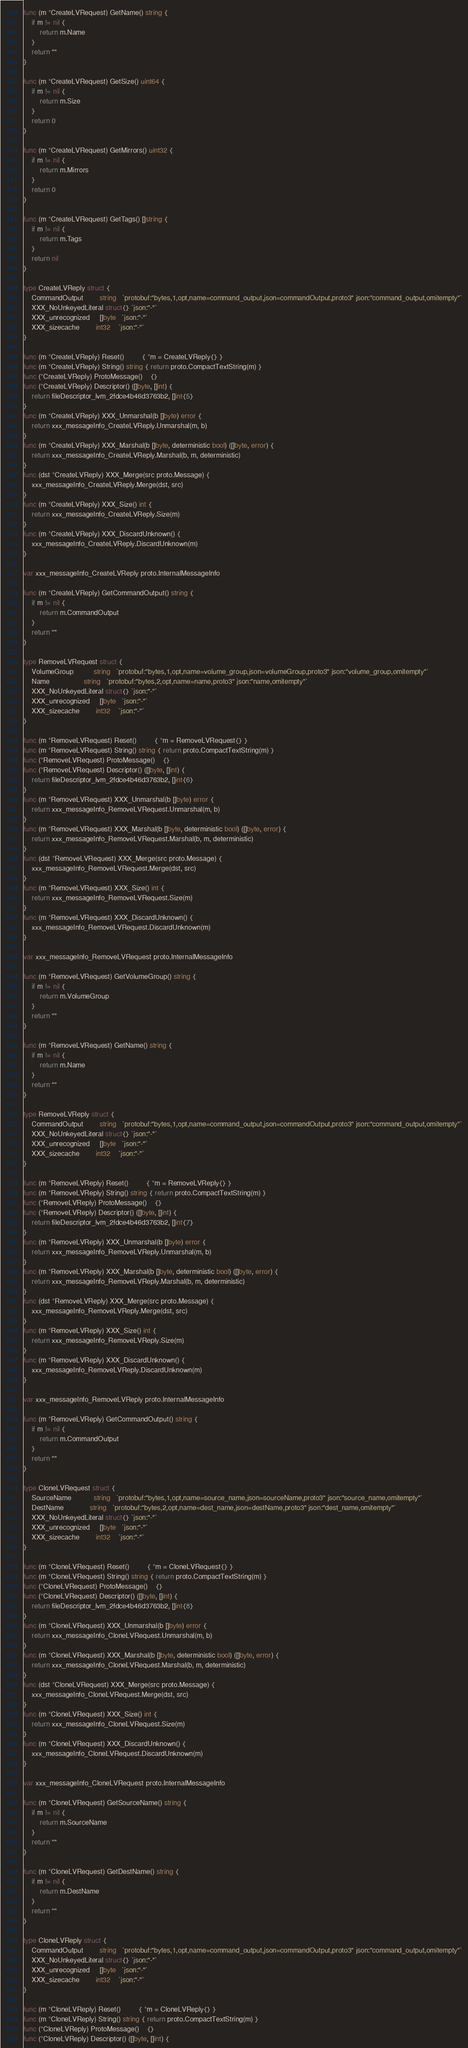<code> <loc_0><loc_0><loc_500><loc_500><_Go_>func (m *CreateLVRequest) GetName() string {
	if m != nil {
		return m.Name
	}
	return ""
}

func (m *CreateLVRequest) GetSize() uint64 {
	if m != nil {
		return m.Size
	}
	return 0
}

func (m *CreateLVRequest) GetMirrors() uint32 {
	if m != nil {
		return m.Mirrors
	}
	return 0
}

func (m *CreateLVRequest) GetTags() []string {
	if m != nil {
		return m.Tags
	}
	return nil
}

type CreateLVReply struct {
	CommandOutput        string   `protobuf:"bytes,1,opt,name=command_output,json=commandOutput,proto3" json:"command_output,omitempty"`
	XXX_NoUnkeyedLiteral struct{} `json:"-"`
	XXX_unrecognized     []byte   `json:"-"`
	XXX_sizecache        int32    `json:"-"`
}

func (m *CreateLVReply) Reset()         { *m = CreateLVReply{} }
func (m *CreateLVReply) String() string { return proto.CompactTextString(m) }
func (*CreateLVReply) ProtoMessage()    {}
func (*CreateLVReply) Descriptor() ([]byte, []int) {
	return fileDescriptor_lvm_2fdce4b46d3763b2, []int{5}
}
func (m *CreateLVReply) XXX_Unmarshal(b []byte) error {
	return xxx_messageInfo_CreateLVReply.Unmarshal(m, b)
}
func (m *CreateLVReply) XXX_Marshal(b []byte, deterministic bool) ([]byte, error) {
	return xxx_messageInfo_CreateLVReply.Marshal(b, m, deterministic)
}
func (dst *CreateLVReply) XXX_Merge(src proto.Message) {
	xxx_messageInfo_CreateLVReply.Merge(dst, src)
}
func (m *CreateLVReply) XXX_Size() int {
	return xxx_messageInfo_CreateLVReply.Size(m)
}
func (m *CreateLVReply) XXX_DiscardUnknown() {
	xxx_messageInfo_CreateLVReply.DiscardUnknown(m)
}

var xxx_messageInfo_CreateLVReply proto.InternalMessageInfo

func (m *CreateLVReply) GetCommandOutput() string {
	if m != nil {
		return m.CommandOutput
	}
	return ""
}

type RemoveLVRequest struct {
	VolumeGroup          string   `protobuf:"bytes,1,opt,name=volume_group,json=volumeGroup,proto3" json:"volume_group,omitempty"`
	Name                 string   `protobuf:"bytes,2,opt,name=name,proto3" json:"name,omitempty"`
	XXX_NoUnkeyedLiteral struct{} `json:"-"`
	XXX_unrecognized     []byte   `json:"-"`
	XXX_sizecache        int32    `json:"-"`
}

func (m *RemoveLVRequest) Reset()         { *m = RemoveLVRequest{} }
func (m *RemoveLVRequest) String() string { return proto.CompactTextString(m) }
func (*RemoveLVRequest) ProtoMessage()    {}
func (*RemoveLVRequest) Descriptor() ([]byte, []int) {
	return fileDescriptor_lvm_2fdce4b46d3763b2, []int{6}
}
func (m *RemoveLVRequest) XXX_Unmarshal(b []byte) error {
	return xxx_messageInfo_RemoveLVRequest.Unmarshal(m, b)
}
func (m *RemoveLVRequest) XXX_Marshal(b []byte, deterministic bool) ([]byte, error) {
	return xxx_messageInfo_RemoveLVRequest.Marshal(b, m, deterministic)
}
func (dst *RemoveLVRequest) XXX_Merge(src proto.Message) {
	xxx_messageInfo_RemoveLVRequest.Merge(dst, src)
}
func (m *RemoveLVRequest) XXX_Size() int {
	return xxx_messageInfo_RemoveLVRequest.Size(m)
}
func (m *RemoveLVRequest) XXX_DiscardUnknown() {
	xxx_messageInfo_RemoveLVRequest.DiscardUnknown(m)
}

var xxx_messageInfo_RemoveLVRequest proto.InternalMessageInfo

func (m *RemoveLVRequest) GetVolumeGroup() string {
	if m != nil {
		return m.VolumeGroup
	}
	return ""
}

func (m *RemoveLVRequest) GetName() string {
	if m != nil {
		return m.Name
	}
	return ""
}

type RemoveLVReply struct {
	CommandOutput        string   `protobuf:"bytes,1,opt,name=command_output,json=commandOutput,proto3" json:"command_output,omitempty"`
	XXX_NoUnkeyedLiteral struct{} `json:"-"`
	XXX_unrecognized     []byte   `json:"-"`
	XXX_sizecache        int32    `json:"-"`
}

func (m *RemoveLVReply) Reset()         { *m = RemoveLVReply{} }
func (m *RemoveLVReply) String() string { return proto.CompactTextString(m) }
func (*RemoveLVReply) ProtoMessage()    {}
func (*RemoveLVReply) Descriptor() ([]byte, []int) {
	return fileDescriptor_lvm_2fdce4b46d3763b2, []int{7}
}
func (m *RemoveLVReply) XXX_Unmarshal(b []byte) error {
	return xxx_messageInfo_RemoveLVReply.Unmarshal(m, b)
}
func (m *RemoveLVReply) XXX_Marshal(b []byte, deterministic bool) ([]byte, error) {
	return xxx_messageInfo_RemoveLVReply.Marshal(b, m, deterministic)
}
func (dst *RemoveLVReply) XXX_Merge(src proto.Message) {
	xxx_messageInfo_RemoveLVReply.Merge(dst, src)
}
func (m *RemoveLVReply) XXX_Size() int {
	return xxx_messageInfo_RemoveLVReply.Size(m)
}
func (m *RemoveLVReply) XXX_DiscardUnknown() {
	xxx_messageInfo_RemoveLVReply.DiscardUnknown(m)
}

var xxx_messageInfo_RemoveLVReply proto.InternalMessageInfo

func (m *RemoveLVReply) GetCommandOutput() string {
	if m != nil {
		return m.CommandOutput
	}
	return ""
}

type CloneLVRequest struct {
	SourceName           string   `protobuf:"bytes,1,opt,name=source_name,json=sourceName,proto3" json:"source_name,omitempty"`
	DestName             string   `protobuf:"bytes,2,opt,name=dest_name,json=destName,proto3" json:"dest_name,omitempty"`
	XXX_NoUnkeyedLiteral struct{} `json:"-"`
	XXX_unrecognized     []byte   `json:"-"`
	XXX_sizecache        int32    `json:"-"`
}

func (m *CloneLVRequest) Reset()         { *m = CloneLVRequest{} }
func (m *CloneLVRequest) String() string { return proto.CompactTextString(m) }
func (*CloneLVRequest) ProtoMessage()    {}
func (*CloneLVRequest) Descriptor() ([]byte, []int) {
	return fileDescriptor_lvm_2fdce4b46d3763b2, []int{8}
}
func (m *CloneLVRequest) XXX_Unmarshal(b []byte) error {
	return xxx_messageInfo_CloneLVRequest.Unmarshal(m, b)
}
func (m *CloneLVRequest) XXX_Marshal(b []byte, deterministic bool) ([]byte, error) {
	return xxx_messageInfo_CloneLVRequest.Marshal(b, m, deterministic)
}
func (dst *CloneLVRequest) XXX_Merge(src proto.Message) {
	xxx_messageInfo_CloneLVRequest.Merge(dst, src)
}
func (m *CloneLVRequest) XXX_Size() int {
	return xxx_messageInfo_CloneLVRequest.Size(m)
}
func (m *CloneLVRequest) XXX_DiscardUnknown() {
	xxx_messageInfo_CloneLVRequest.DiscardUnknown(m)
}

var xxx_messageInfo_CloneLVRequest proto.InternalMessageInfo

func (m *CloneLVRequest) GetSourceName() string {
	if m != nil {
		return m.SourceName
	}
	return ""
}

func (m *CloneLVRequest) GetDestName() string {
	if m != nil {
		return m.DestName
	}
	return ""
}

type CloneLVReply struct {
	CommandOutput        string   `protobuf:"bytes,1,opt,name=command_output,json=commandOutput,proto3" json:"command_output,omitempty"`
	XXX_NoUnkeyedLiteral struct{} `json:"-"`
	XXX_unrecognized     []byte   `json:"-"`
	XXX_sizecache        int32    `json:"-"`
}

func (m *CloneLVReply) Reset()         { *m = CloneLVReply{} }
func (m *CloneLVReply) String() string { return proto.CompactTextString(m) }
func (*CloneLVReply) ProtoMessage()    {}
func (*CloneLVReply) Descriptor() ([]byte, []int) {</code> 